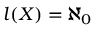<formula> <loc_0><loc_0><loc_500><loc_500>l ( X ) = \aleph _ { 0 }</formula> 